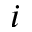<formula> <loc_0><loc_0><loc_500><loc_500>_ { i }</formula> 